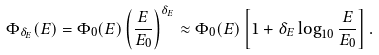Convert formula to latex. <formula><loc_0><loc_0><loc_500><loc_500>\Phi _ { \delta _ { E } } ( E ) = \Phi _ { 0 } ( E ) \left ( \frac { E } { E _ { 0 } } \right ) ^ { \delta _ { E } } \approx \Phi _ { 0 } ( E ) \left [ 1 + \delta _ { E } \log _ { 1 0 } \frac { E } { E _ { 0 } } \right ] .</formula> 